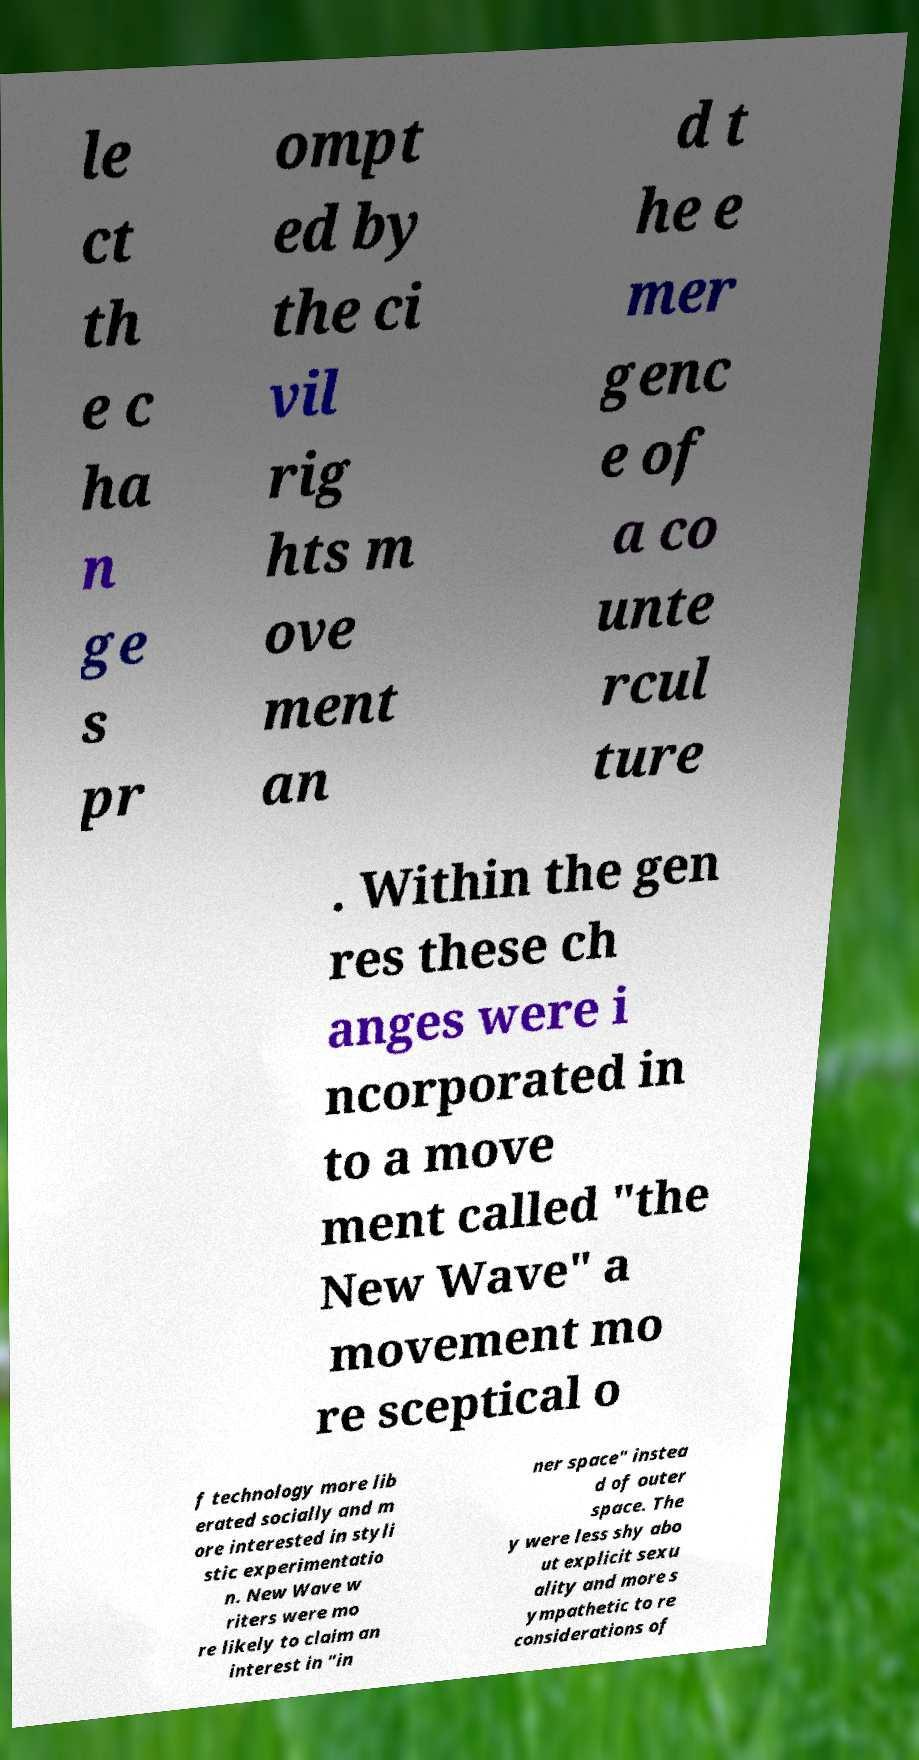There's text embedded in this image that I need extracted. Can you transcribe it verbatim? le ct th e c ha n ge s pr ompt ed by the ci vil rig hts m ove ment an d t he e mer genc e of a co unte rcul ture . Within the gen res these ch anges were i ncorporated in to a move ment called "the New Wave" a movement mo re sceptical o f technology more lib erated socially and m ore interested in styli stic experimentatio n. New Wave w riters were mo re likely to claim an interest in "in ner space" instea d of outer space. The y were less shy abo ut explicit sexu ality and more s ympathetic to re considerations of 